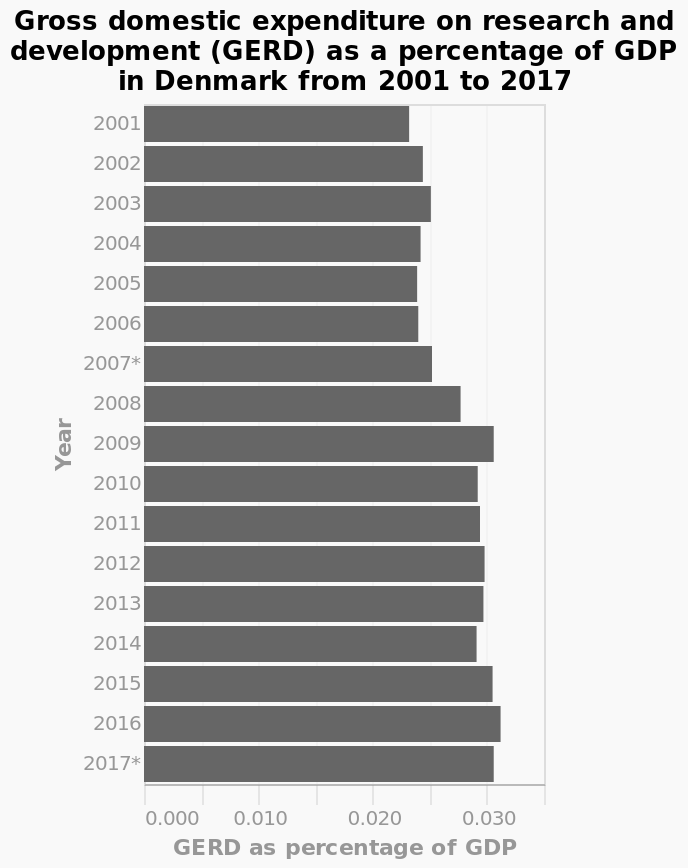<image>
Offer a thorough analysis of the image. Gerd has gotten higher over the yearsThe most Gerd was in 2009. What does GERD stand for in the context of the bar plot?  GERD stands for Gross domestic expenditure on research and development. Describe the following image in detail Gross domestic expenditure on research and development (GERD) as a percentage of GDP in Denmark from 2001 to 2017 is a bar plot. There is a linear scale of range 0.000 to 0.035 along the x-axis, labeled GERD as percentage of GDP. A categorical scale from 2001 to 2017* can be seen along the y-axis, marked Year. 